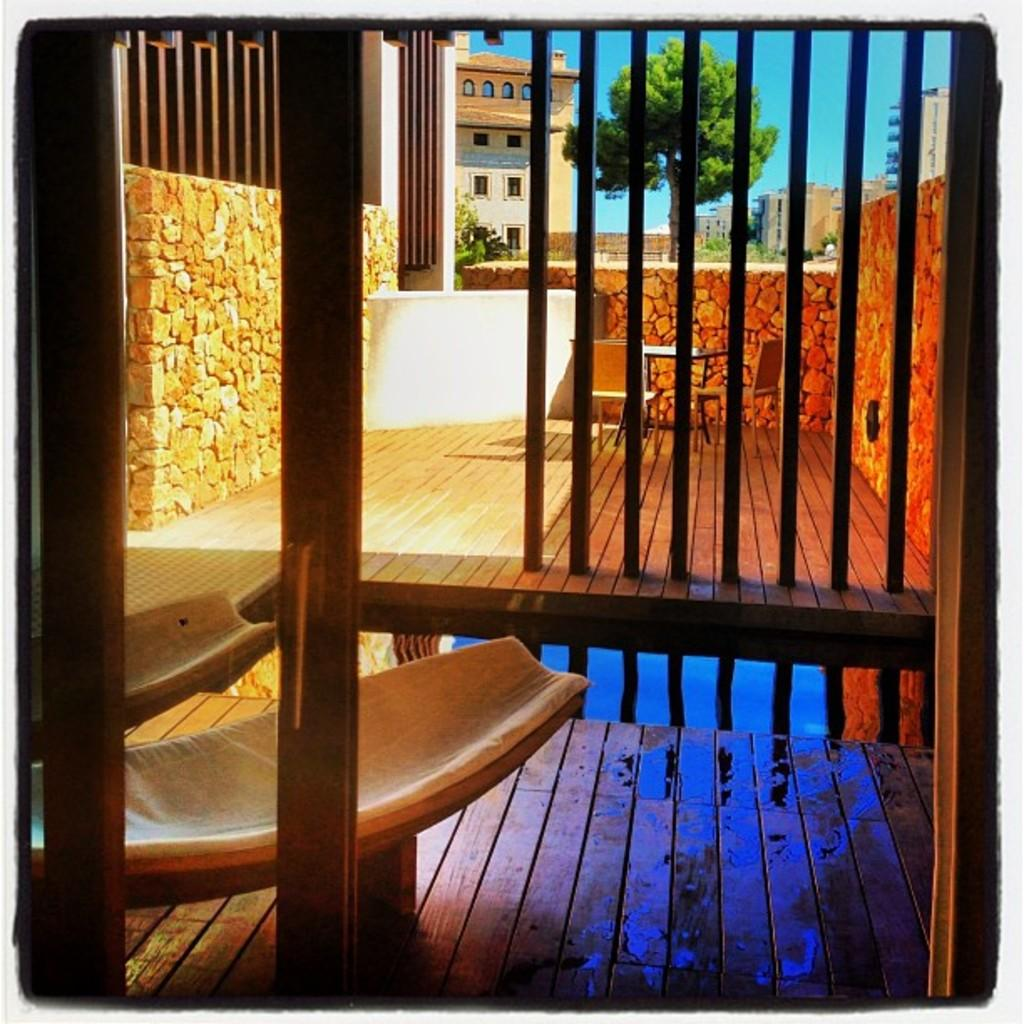What type of furniture is present in the image? There are wooden tables and chairs in the image. What is located behind the tables? There is a wall behind the tables. What can be seen in the background of the image? Buildings, a tree, and the sky are visible in the background of the image. How many geese are sitting on the wooden tables in the image? There are no geese present in the image; it features wooden tables and chairs. What is the profit margin of the business operating in the image? There is no information about a business or profit margin in the image. 